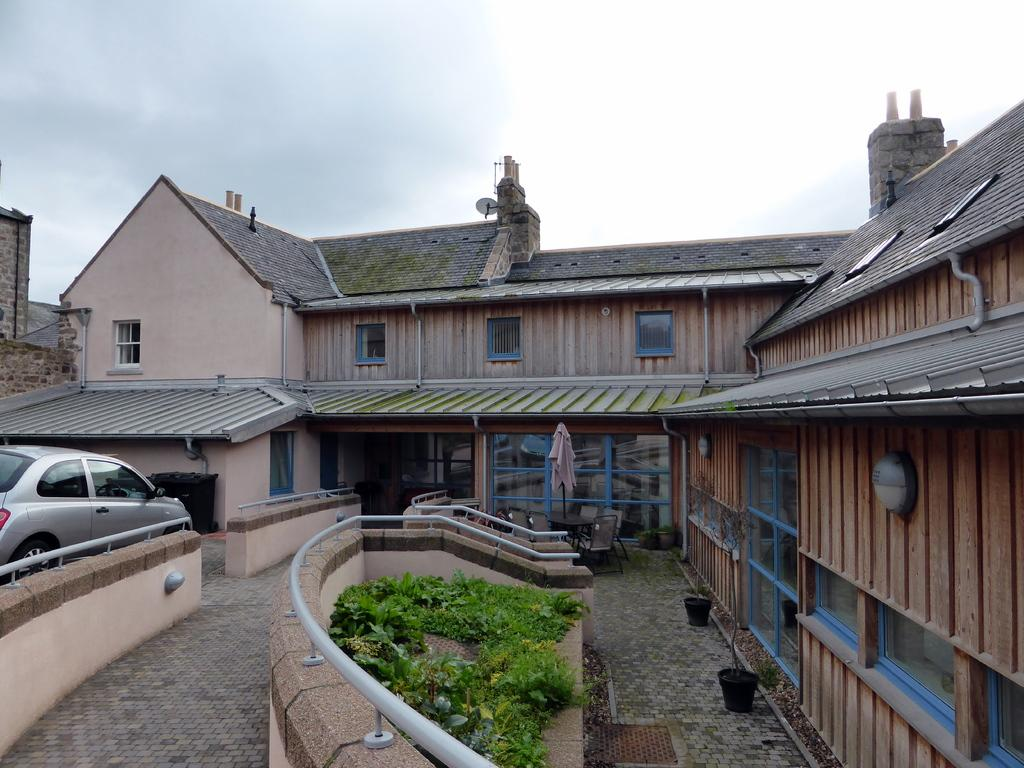What type of structure is present in the image? There is a shelter house in the image. Where is the car located in the image? The car is on the left side of the image. What type of vegetation is at the bottom of the image? There are plants at the bottom of the image. What is visible at the top of the image? The sky is visible at the top of the image. What type of coil is wrapped around the shelter house in the image? There is no coil present in the image; it only features a shelter house, a car, plants, and the sky. Can you see anyone giving a kiss in the image? There is no kissing activity depicted in the image. 